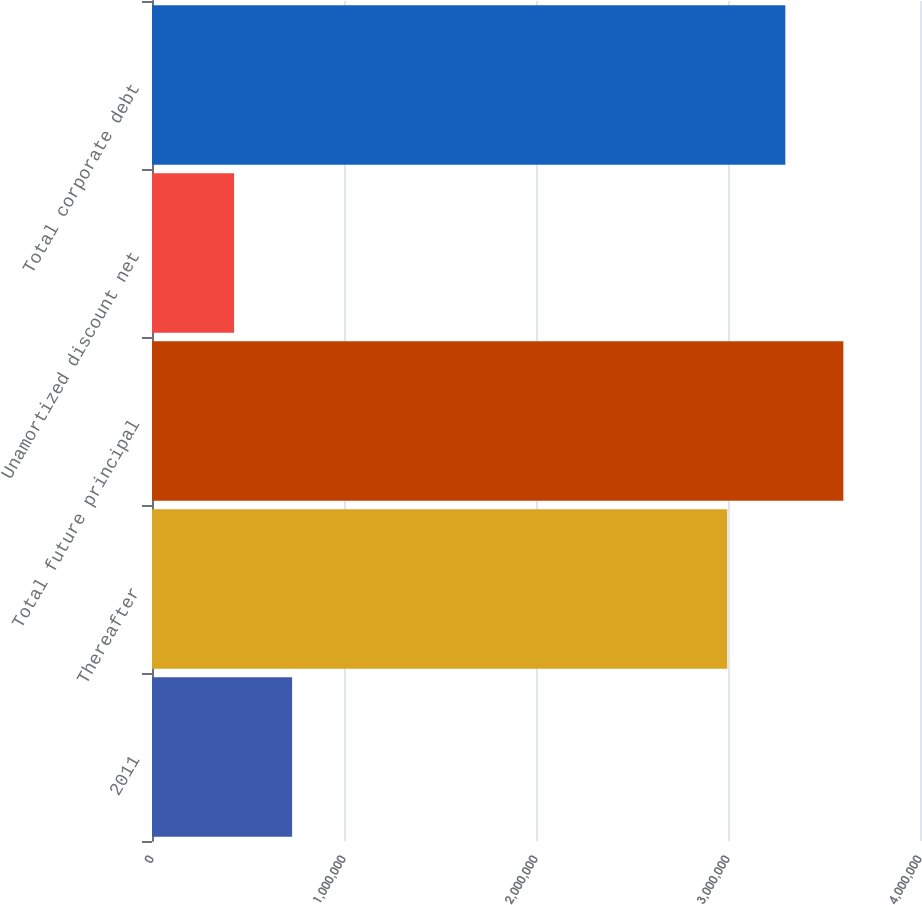Convert chart to OTSL. <chart><loc_0><loc_0><loc_500><loc_500><bar_chart><fcel>2011<fcel>Thereafter<fcel>Total future principal<fcel>Unamortized discount net<fcel>Total corporate debt<nl><fcel>729724<fcel>2.99634e+06<fcel>3.60088e+06<fcel>427454<fcel>3.29861e+06<nl></chart> 